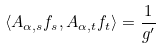Convert formula to latex. <formula><loc_0><loc_0><loc_500><loc_500>\langle A _ { \alpha , s } f _ { s } , A _ { \alpha , t } f _ { t } \rangle = \frac { 1 } { g ^ { \prime } }</formula> 